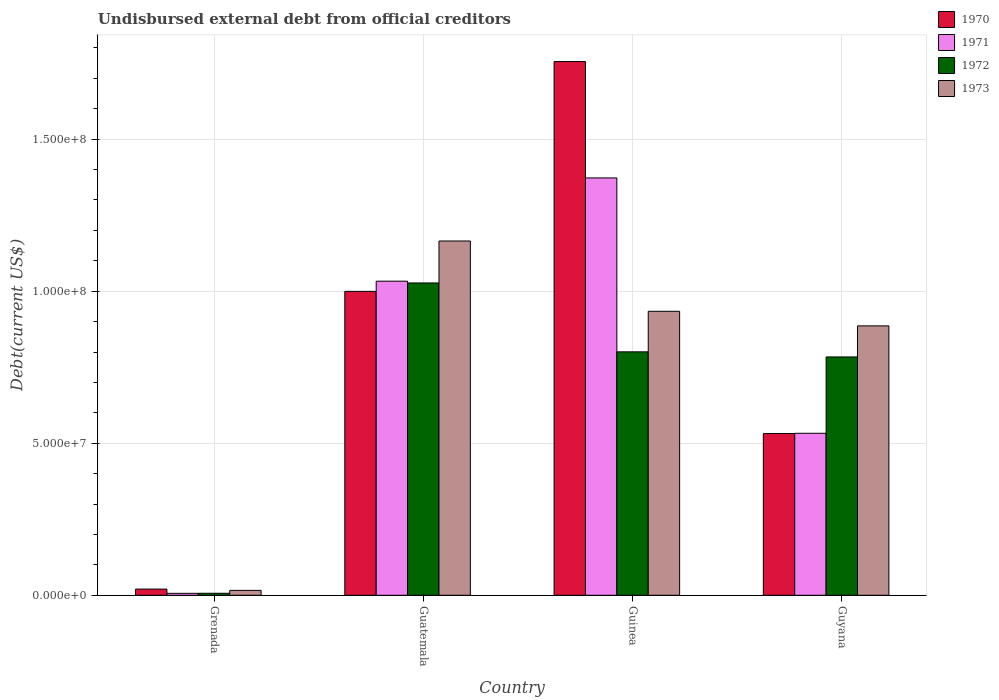Are the number of bars per tick equal to the number of legend labels?
Provide a short and direct response. Yes. How many bars are there on the 4th tick from the left?
Your response must be concise. 4. What is the label of the 4th group of bars from the left?
Your answer should be compact. Guyana. What is the total debt in 1970 in Guinea?
Ensure brevity in your answer.  1.76e+08. Across all countries, what is the maximum total debt in 1971?
Keep it short and to the point. 1.37e+08. Across all countries, what is the minimum total debt in 1970?
Give a very brief answer. 2.04e+06. In which country was the total debt in 1971 maximum?
Make the answer very short. Guinea. In which country was the total debt in 1971 minimum?
Offer a very short reply. Grenada. What is the total total debt in 1973 in the graph?
Your answer should be compact. 3.00e+08. What is the difference between the total debt in 1973 in Guinea and that in Guyana?
Your answer should be very brief. 4.80e+06. What is the difference between the total debt in 1970 in Guinea and the total debt in 1971 in Guyana?
Keep it short and to the point. 1.22e+08. What is the average total debt in 1972 per country?
Offer a terse response. 6.54e+07. What is the difference between the total debt of/in 1973 and total debt of/in 1971 in Guyana?
Make the answer very short. 3.53e+07. In how many countries, is the total debt in 1972 greater than 110000000 US$?
Your response must be concise. 0. What is the ratio of the total debt in 1970 in Guatemala to that in Guyana?
Make the answer very short. 1.88. What is the difference between the highest and the second highest total debt in 1971?
Offer a very short reply. 8.40e+07. What is the difference between the highest and the lowest total debt in 1970?
Offer a terse response. 1.73e+08. In how many countries, is the total debt in 1973 greater than the average total debt in 1973 taken over all countries?
Offer a terse response. 3. What does the 2nd bar from the left in Guatemala represents?
Keep it short and to the point. 1971. What does the 4th bar from the right in Grenada represents?
Keep it short and to the point. 1970. Is it the case that in every country, the sum of the total debt in 1973 and total debt in 1971 is greater than the total debt in 1970?
Offer a very short reply. Yes. Are all the bars in the graph horizontal?
Keep it short and to the point. No. Does the graph contain any zero values?
Your answer should be very brief. No. How many legend labels are there?
Make the answer very short. 4. How are the legend labels stacked?
Your answer should be very brief. Vertical. What is the title of the graph?
Provide a succinct answer. Undisbursed external debt from official creditors. Does "1970" appear as one of the legend labels in the graph?
Offer a terse response. Yes. What is the label or title of the X-axis?
Ensure brevity in your answer.  Country. What is the label or title of the Y-axis?
Offer a very short reply. Debt(current US$). What is the Debt(current US$) of 1970 in Grenada?
Offer a terse response. 2.04e+06. What is the Debt(current US$) of 1971 in Grenada?
Keep it short and to the point. 6.39e+05. What is the Debt(current US$) in 1972 in Grenada?
Your response must be concise. 6.57e+05. What is the Debt(current US$) of 1973 in Grenada?
Your response must be concise. 1.61e+06. What is the Debt(current US$) in 1970 in Guatemala?
Your answer should be compact. 9.99e+07. What is the Debt(current US$) in 1971 in Guatemala?
Your answer should be compact. 1.03e+08. What is the Debt(current US$) of 1972 in Guatemala?
Make the answer very short. 1.03e+08. What is the Debt(current US$) in 1973 in Guatemala?
Make the answer very short. 1.17e+08. What is the Debt(current US$) of 1970 in Guinea?
Make the answer very short. 1.76e+08. What is the Debt(current US$) in 1971 in Guinea?
Make the answer very short. 1.37e+08. What is the Debt(current US$) in 1972 in Guinea?
Offer a terse response. 8.01e+07. What is the Debt(current US$) of 1973 in Guinea?
Offer a very short reply. 9.34e+07. What is the Debt(current US$) of 1970 in Guyana?
Your response must be concise. 5.32e+07. What is the Debt(current US$) in 1971 in Guyana?
Give a very brief answer. 5.33e+07. What is the Debt(current US$) in 1972 in Guyana?
Make the answer very short. 7.84e+07. What is the Debt(current US$) of 1973 in Guyana?
Offer a very short reply. 8.86e+07. Across all countries, what is the maximum Debt(current US$) of 1970?
Offer a very short reply. 1.76e+08. Across all countries, what is the maximum Debt(current US$) of 1971?
Ensure brevity in your answer.  1.37e+08. Across all countries, what is the maximum Debt(current US$) of 1972?
Provide a short and direct response. 1.03e+08. Across all countries, what is the maximum Debt(current US$) of 1973?
Offer a very short reply. 1.17e+08. Across all countries, what is the minimum Debt(current US$) in 1970?
Your answer should be compact. 2.04e+06. Across all countries, what is the minimum Debt(current US$) of 1971?
Your answer should be compact. 6.39e+05. Across all countries, what is the minimum Debt(current US$) in 1972?
Ensure brevity in your answer.  6.57e+05. Across all countries, what is the minimum Debt(current US$) of 1973?
Provide a succinct answer. 1.61e+06. What is the total Debt(current US$) of 1970 in the graph?
Ensure brevity in your answer.  3.31e+08. What is the total Debt(current US$) of 1971 in the graph?
Offer a very short reply. 2.94e+08. What is the total Debt(current US$) of 1972 in the graph?
Make the answer very short. 2.62e+08. What is the total Debt(current US$) of 1973 in the graph?
Provide a short and direct response. 3.00e+08. What is the difference between the Debt(current US$) of 1970 in Grenada and that in Guatemala?
Your answer should be compact. -9.79e+07. What is the difference between the Debt(current US$) in 1971 in Grenada and that in Guatemala?
Keep it short and to the point. -1.03e+08. What is the difference between the Debt(current US$) of 1972 in Grenada and that in Guatemala?
Give a very brief answer. -1.02e+08. What is the difference between the Debt(current US$) in 1973 in Grenada and that in Guatemala?
Your answer should be very brief. -1.15e+08. What is the difference between the Debt(current US$) in 1970 in Grenada and that in Guinea?
Ensure brevity in your answer.  -1.73e+08. What is the difference between the Debt(current US$) in 1971 in Grenada and that in Guinea?
Your answer should be compact. -1.37e+08. What is the difference between the Debt(current US$) of 1972 in Grenada and that in Guinea?
Your answer should be compact. -7.94e+07. What is the difference between the Debt(current US$) of 1973 in Grenada and that in Guinea?
Offer a very short reply. -9.18e+07. What is the difference between the Debt(current US$) of 1970 in Grenada and that in Guyana?
Offer a very short reply. -5.12e+07. What is the difference between the Debt(current US$) in 1971 in Grenada and that in Guyana?
Give a very brief answer. -5.26e+07. What is the difference between the Debt(current US$) in 1972 in Grenada and that in Guyana?
Provide a short and direct response. -7.77e+07. What is the difference between the Debt(current US$) in 1973 in Grenada and that in Guyana?
Offer a very short reply. -8.70e+07. What is the difference between the Debt(current US$) in 1970 in Guatemala and that in Guinea?
Your answer should be very brief. -7.56e+07. What is the difference between the Debt(current US$) in 1971 in Guatemala and that in Guinea?
Ensure brevity in your answer.  -3.40e+07. What is the difference between the Debt(current US$) of 1972 in Guatemala and that in Guinea?
Make the answer very short. 2.27e+07. What is the difference between the Debt(current US$) in 1973 in Guatemala and that in Guinea?
Provide a short and direct response. 2.31e+07. What is the difference between the Debt(current US$) in 1970 in Guatemala and that in Guyana?
Offer a terse response. 4.67e+07. What is the difference between the Debt(current US$) in 1971 in Guatemala and that in Guyana?
Your response must be concise. 5.00e+07. What is the difference between the Debt(current US$) of 1972 in Guatemala and that in Guyana?
Ensure brevity in your answer.  2.43e+07. What is the difference between the Debt(current US$) in 1973 in Guatemala and that in Guyana?
Your answer should be very brief. 2.79e+07. What is the difference between the Debt(current US$) in 1970 in Guinea and that in Guyana?
Your response must be concise. 1.22e+08. What is the difference between the Debt(current US$) of 1971 in Guinea and that in Guyana?
Give a very brief answer. 8.40e+07. What is the difference between the Debt(current US$) in 1972 in Guinea and that in Guyana?
Make the answer very short. 1.68e+06. What is the difference between the Debt(current US$) of 1973 in Guinea and that in Guyana?
Provide a short and direct response. 4.80e+06. What is the difference between the Debt(current US$) in 1970 in Grenada and the Debt(current US$) in 1971 in Guatemala?
Offer a terse response. -1.01e+08. What is the difference between the Debt(current US$) in 1970 in Grenada and the Debt(current US$) in 1972 in Guatemala?
Your answer should be compact. -1.01e+08. What is the difference between the Debt(current US$) of 1970 in Grenada and the Debt(current US$) of 1973 in Guatemala?
Your answer should be very brief. -1.14e+08. What is the difference between the Debt(current US$) in 1971 in Grenada and the Debt(current US$) in 1972 in Guatemala?
Make the answer very short. -1.02e+08. What is the difference between the Debt(current US$) of 1971 in Grenada and the Debt(current US$) of 1973 in Guatemala?
Give a very brief answer. -1.16e+08. What is the difference between the Debt(current US$) in 1972 in Grenada and the Debt(current US$) in 1973 in Guatemala?
Your answer should be compact. -1.16e+08. What is the difference between the Debt(current US$) in 1970 in Grenada and the Debt(current US$) in 1971 in Guinea?
Your answer should be very brief. -1.35e+08. What is the difference between the Debt(current US$) in 1970 in Grenada and the Debt(current US$) in 1972 in Guinea?
Make the answer very short. -7.80e+07. What is the difference between the Debt(current US$) in 1970 in Grenada and the Debt(current US$) in 1973 in Guinea?
Your answer should be compact. -9.14e+07. What is the difference between the Debt(current US$) of 1971 in Grenada and the Debt(current US$) of 1972 in Guinea?
Keep it short and to the point. -7.94e+07. What is the difference between the Debt(current US$) of 1971 in Grenada and the Debt(current US$) of 1973 in Guinea?
Your response must be concise. -9.28e+07. What is the difference between the Debt(current US$) in 1972 in Grenada and the Debt(current US$) in 1973 in Guinea?
Give a very brief answer. -9.27e+07. What is the difference between the Debt(current US$) of 1970 in Grenada and the Debt(current US$) of 1971 in Guyana?
Offer a terse response. -5.12e+07. What is the difference between the Debt(current US$) in 1970 in Grenada and the Debt(current US$) in 1972 in Guyana?
Your answer should be compact. -7.63e+07. What is the difference between the Debt(current US$) of 1970 in Grenada and the Debt(current US$) of 1973 in Guyana?
Give a very brief answer. -8.66e+07. What is the difference between the Debt(current US$) of 1971 in Grenada and the Debt(current US$) of 1972 in Guyana?
Provide a short and direct response. -7.77e+07. What is the difference between the Debt(current US$) in 1971 in Grenada and the Debt(current US$) in 1973 in Guyana?
Your answer should be compact. -8.80e+07. What is the difference between the Debt(current US$) of 1972 in Grenada and the Debt(current US$) of 1973 in Guyana?
Give a very brief answer. -8.79e+07. What is the difference between the Debt(current US$) in 1970 in Guatemala and the Debt(current US$) in 1971 in Guinea?
Keep it short and to the point. -3.73e+07. What is the difference between the Debt(current US$) in 1970 in Guatemala and the Debt(current US$) in 1972 in Guinea?
Your answer should be compact. 1.99e+07. What is the difference between the Debt(current US$) in 1970 in Guatemala and the Debt(current US$) in 1973 in Guinea?
Offer a terse response. 6.55e+06. What is the difference between the Debt(current US$) of 1971 in Guatemala and the Debt(current US$) of 1972 in Guinea?
Offer a terse response. 2.32e+07. What is the difference between the Debt(current US$) of 1971 in Guatemala and the Debt(current US$) of 1973 in Guinea?
Your response must be concise. 9.90e+06. What is the difference between the Debt(current US$) in 1972 in Guatemala and the Debt(current US$) in 1973 in Guinea?
Make the answer very short. 9.32e+06. What is the difference between the Debt(current US$) of 1970 in Guatemala and the Debt(current US$) of 1971 in Guyana?
Offer a very short reply. 4.67e+07. What is the difference between the Debt(current US$) in 1970 in Guatemala and the Debt(current US$) in 1972 in Guyana?
Offer a very short reply. 2.16e+07. What is the difference between the Debt(current US$) in 1970 in Guatemala and the Debt(current US$) in 1973 in Guyana?
Ensure brevity in your answer.  1.14e+07. What is the difference between the Debt(current US$) in 1971 in Guatemala and the Debt(current US$) in 1972 in Guyana?
Provide a succinct answer. 2.49e+07. What is the difference between the Debt(current US$) of 1971 in Guatemala and the Debt(current US$) of 1973 in Guyana?
Offer a terse response. 1.47e+07. What is the difference between the Debt(current US$) in 1972 in Guatemala and the Debt(current US$) in 1973 in Guyana?
Give a very brief answer. 1.41e+07. What is the difference between the Debt(current US$) in 1970 in Guinea and the Debt(current US$) in 1971 in Guyana?
Your response must be concise. 1.22e+08. What is the difference between the Debt(current US$) in 1970 in Guinea and the Debt(current US$) in 1972 in Guyana?
Ensure brevity in your answer.  9.71e+07. What is the difference between the Debt(current US$) of 1970 in Guinea and the Debt(current US$) of 1973 in Guyana?
Your answer should be very brief. 8.69e+07. What is the difference between the Debt(current US$) of 1971 in Guinea and the Debt(current US$) of 1972 in Guyana?
Offer a terse response. 5.89e+07. What is the difference between the Debt(current US$) of 1971 in Guinea and the Debt(current US$) of 1973 in Guyana?
Ensure brevity in your answer.  4.87e+07. What is the difference between the Debt(current US$) of 1972 in Guinea and the Debt(current US$) of 1973 in Guyana?
Keep it short and to the point. -8.54e+06. What is the average Debt(current US$) of 1970 per country?
Provide a succinct answer. 8.27e+07. What is the average Debt(current US$) in 1971 per country?
Give a very brief answer. 7.36e+07. What is the average Debt(current US$) of 1972 per country?
Provide a short and direct response. 6.54e+07. What is the average Debt(current US$) in 1973 per country?
Make the answer very short. 7.50e+07. What is the difference between the Debt(current US$) of 1970 and Debt(current US$) of 1971 in Grenada?
Offer a terse response. 1.40e+06. What is the difference between the Debt(current US$) in 1970 and Debt(current US$) in 1972 in Grenada?
Ensure brevity in your answer.  1.38e+06. What is the difference between the Debt(current US$) of 1970 and Debt(current US$) of 1973 in Grenada?
Offer a terse response. 4.26e+05. What is the difference between the Debt(current US$) of 1971 and Debt(current US$) of 1972 in Grenada?
Your answer should be compact. -1.80e+04. What is the difference between the Debt(current US$) in 1971 and Debt(current US$) in 1973 in Grenada?
Offer a terse response. -9.72e+05. What is the difference between the Debt(current US$) in 1972 and Debt(current US$) in 1973 in Grenada?
Your response must be concise. -9.54e+05. What is the difference between the Debt(current US$) in 1970 and Debt(current US$) in 1971 in Guatemala?
Your answer should be compact. -3.35e+06. What is the difference between the Debt(current US$) in 1970 and Debt(current US$) in 1972 in Guatemala?
Make the answer very short. -2.77e+06. What is the difference between the Debt(current US$) of 1970 and Debt(current US$) of 1973 in Guatemala?
Provide a short and direct response. -1.66e+07. What is the difference between the Debt(current US$) in 1971 and Debt(current US$) in 1972 in Guatemala?
Ensure brevity in your answer.  5.87e+05. What is the difference between the Debt(current US$) of 1971 and Debt(current US$) of 1973 in Guatemala?
Keep it short and to the point. -1.32e+07. What is the difference between the Debt(current US$) of 1972 and Debt(current US$) of 1973 in Guatemala?
Keep it short and to the point. -1.38e+07. What is the difference between the Debt(current US$) in 1970 and Debt(current US$) in 1971 in Guinea?
Give a very brief answer. 3.83e+07. What is the difference between the Debt(current US$) of 1970 and Debt(current US$) of 1972 in Guinea?
Give a very brief answer. 9.55e+07. What is the difference between the Debt(current US$) of 1970 and Debt(current US$) of 1973 in Guinea?
Your answer should be compact. 8.21e+07. What is the difference between the Debt(current US$) of 1971 and Debt(current US$) of 1972 in Guinea?
Provide a succinct answer. 5.72e+07. What is the difference between the Debt(current US$) of 1971 and Debt(current US$) of 1973 in Guinea?
Provide a succinct answer. 4.39e+07. What is the difference between the Debt(current US$) in 1972 and Debt(current US$) in 1973 in Guinea?
Ensure brevity in your answer.  -1.33e+07. What is the difference between the Debt(current US$) in 1970 and Debt(current US$) in 1971 in Guyana?
Your answer should be compact. -7.30e+04. What is the difference between the Debt(current US$) in 1970 and Debt(current US$) in 1972 in Guyana?
Give a very brief answer. -2.52e+07. What is the difference between the Debt(current US$) in 1970 and Debt(current US$) in 1973 in Guyana?
Provide a short and direct response. -3.54e+07. What is the difference between the Debt(current US$) of 1971 and Debt(current US$) of 1972 in Guyana?
Give a very brief answer. -2.51e+07. What is the difference between the Debt(current US$) of 1971 and Debt(current US$) of 1973 in Guyana?
Provide a succinct answer. -3.53e+07. What is the difference between the Debt(current US$) in 1972 and Debt(current US$) in 1973 in Guyana?
Give a very brief answer. -1.02e+07. What is the ratio of the Debt(current US$) of 1970 in Grenada to that in Guatemala?
Your answer should be very brief. 0.02. What is the ratio of the Debt(current US$) in 1971 in Grenada to that in Guatemala?
Give a very brief answer. 0.01. What is the ratio of the Debt(current US$) in 1972 in Grenada to that in Guatemala?
Your answer should be compact. 0.01. What is the ratio of the Debt(current US$) of 1973 in Grenada to that in Guatemala?
Keep it short and to the point. 0.01. What is the ratio of the Debt(current US$) of 1970 in Grenada to that in Guinea?
Give a very brief answer. 0.01. What is the ratio of the Debt(current US$) of 1971 in Grenada to that in Guinea?
Offer a very short reply. 0. What is the ratio of the Debt(current US$) of 1972 in Grenada to that in Guinea?
Your response must be concise. 0.01. What is the ratio of the Debt(current US$) of 1973 in Grenada to that in Guinea?
Your answer should be very brief. 0.02. What is the ratio of the Debt(current US$) in 1970 in Grenada to that in Guyana?
Offer a terse response. 0.04. What is the ratio of the Debt(current US$) of 1971 in Grenada to that in Guyana?
Keep it short and to the point. 0.01. What is the ratio of the Debt(current US$) in 1972 in Grenada to that in Guyana?
Make the answer very short. 0.01. What is the ratio of the Debt(current US$) of 1973 in Grenada to that in Guyana?
Your response must be concise. 0.02. What is the ratio of the Debt(current US$) of 1970 in Guatemala to that in Guinea?
Your answer should be very brief. 0.57. What is the ratio of the Debt(current US$) in 1971 in Guatemala to that in Guinea?
Provide a succinct answer. 0.75. What is the ratio of the Debt(current US$) in 1972 in Guatemala to that in Guinea?
Provide a short and direct response. 1.28. What is the ratio of the Debt(current US$) in 1973 in Guatemala to that in Guinea?
Keep it short and to the point. 1.25. What is the ratio of the Debt(current US$) of 1970 in Guatemala to that in Guyana?
Your response must be concise. 1.88. What is the ratio of the Debt(current US$) in 1971 in Guatemala to that in Guyana?
Offer a very short reply. 1.94. What is the ratio of the Debt(current US$) in 1972 in Guatemala to that in Guyana?
Keep it short and to the point. 1.31. What is the ratio of the Debt(current US$) in 1973 in Guatemala to that in Guyana?
Offer a very short reply. 1.32. What is the ratio of the Debt(current US$) in 1970 in Guinea to that in Guyana?
Your answer should be compact. 3.3. What is the ratio of the Debt(current US$) in 1971 in Guinea to that in Guyana?
Offer a very short reply. 2.58. What is the ratio of the Debt(current US$) of 1972 in Guinea to that in Guyana?
Offer a terse response. 1.02. What is the ratio of the Debt(current US$) of 1973 in Guinea to that in Guyana?
Your response must be concise. 1.05. What is the difference between the highest and the second highest Debt(current US$) in 1970?
Provide a short and direct response. 7.56e+07. What is the difference between the highest and the second highest Debt(current US$) in 1971?
Make the answer very short. 3.40e+07. What is the difference between the highest and the second highest Debt(current US$) in 1972?
Ensure brevity in your answer.  2.27e+07. What is the difference between the highest and the second highest Debt(current US$) of 1973?
Keep it short and to the point. 2.31e+07. What is the difference between the highest and the lowest Debt(current US$) of 1970?
Your answer should be very brief. 1.73e+08. What is the difference between the highest and the lowest Debt(current US$) of 1971?
Give a very brief answer. 1.37e+08. What is the difference between the highest and the lowest Debt(current US$) of 1972?
Ensure brevity in your answer.  1.02e+08. What is the difference between the highest and the lowest Debt(current US$) of 1973?
Ensure brevity in your answer.  1.15e+08. 